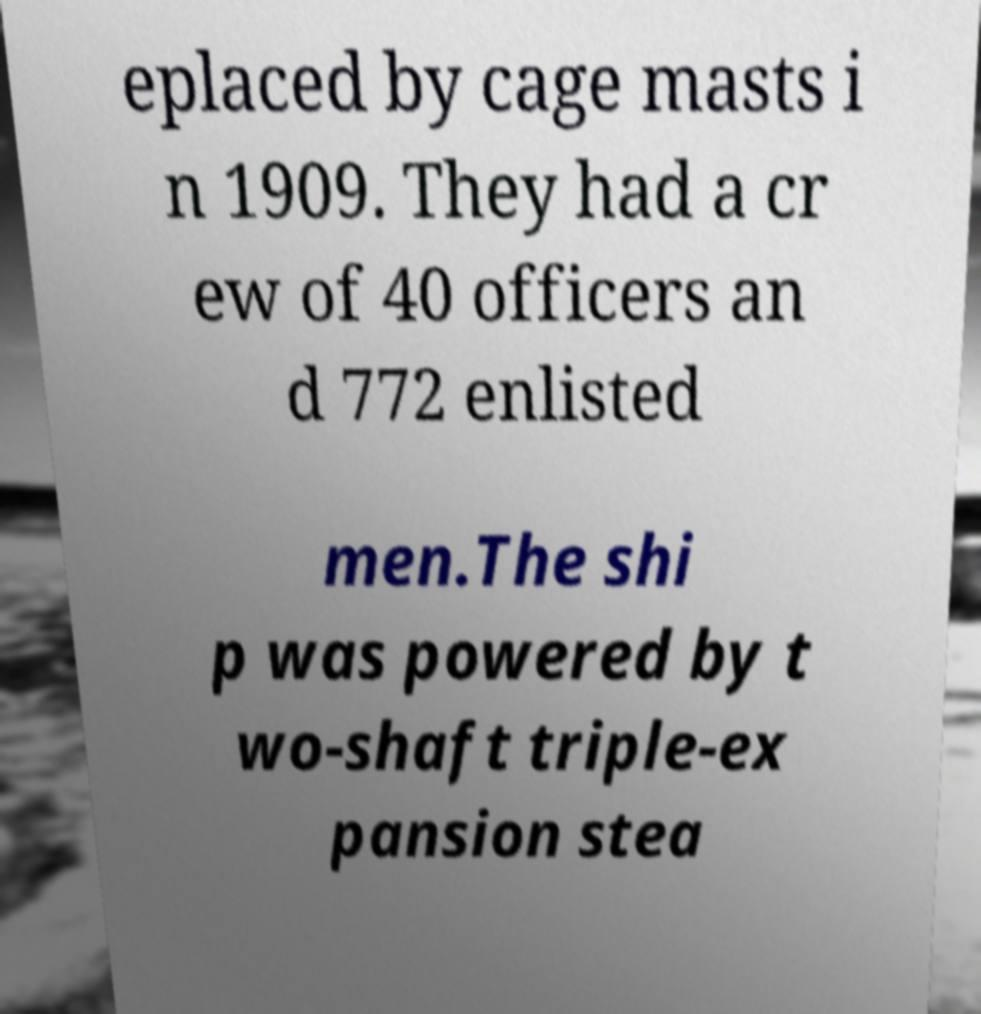Please read and relay the text visible in this image. What does it say? eplaced by cage masts i n 1909. They had a cr ew of 40 officers an d 772 enlisted men.The shi p was powered by t wo-shaft triple-ex pansion stea 